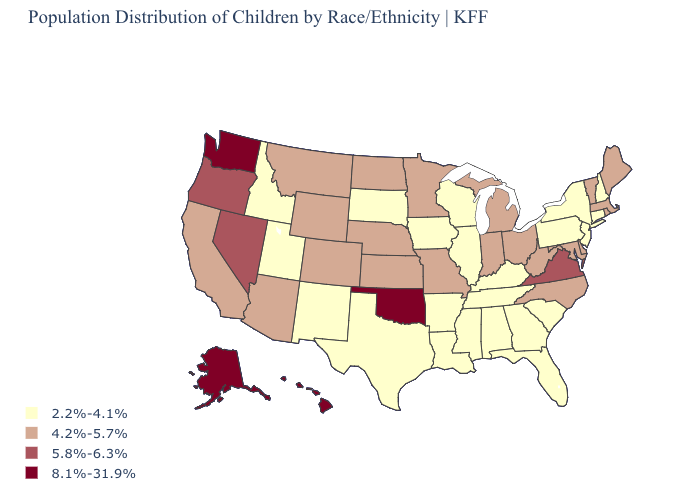Among the states that border New Jersey , does Delaware have the lowest value?
Quick response, please. No. What is the highest value in the West ?
Short answer required. 8.1%-31.9%. Name the states that have a value in the range 2.2%-4.1%?
Write a very short answer. Alabama, Arkansas, Connecticut, Florida, Georgia, Idaho, Illinois, Iowa, Kentucky, Louisiana, Mississippi, New Hampshire, New Jersey, New Mexico, New York, Pennsylvania, South Carolina, South Dakota, Tennessee, Texas, Utah, Wisconsin. What is the value of New Mexico?
Give a very brief answer. 2.2%-4.1%. Which states have the lowest value in the MidWest?
Be succinct. Illinois, Iowa, South Dakota, Wisconsin. Does Rhode Island have the same value as Wyoming?
Keep it brief. Yes. What is the highest value in states that border Missouri?
Write a very short answer. 8.1%-31.9%. Which states have the lowest value in the MidWest?
Be succinct. Illinois, Iowa, South Dakota, Wisconsin. Name the states that have a value in the range 5.8%-6.3%?
Concise answer only. Nevada, Oregon, Virginia. What is the lowest value in the USA?
Keep it brief. 2.2%-4.1%. What is the lowest value in the USA?
Answer briefly. 2.2%-4.1%. What is the value of Tennessee?
Write a very short answer. 2.2%-4.1%. What is the value of Louisiana?
Give a very brief answer. 2.2%-4.1%. What is the lowest value in the USA?
Keep it brief. 2.2%-4.1%. Name the states that have a value in the range 8.1%-31.9%?
Short answer required. Alaska, Hawaii, Oklahoma, Washington. 